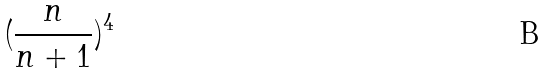Convert formula to latex. <formula><loc_0><loc_0><loc_500><loc_500>( \frac { n } { n + 1 } ) ^ { 4 }</formula> 